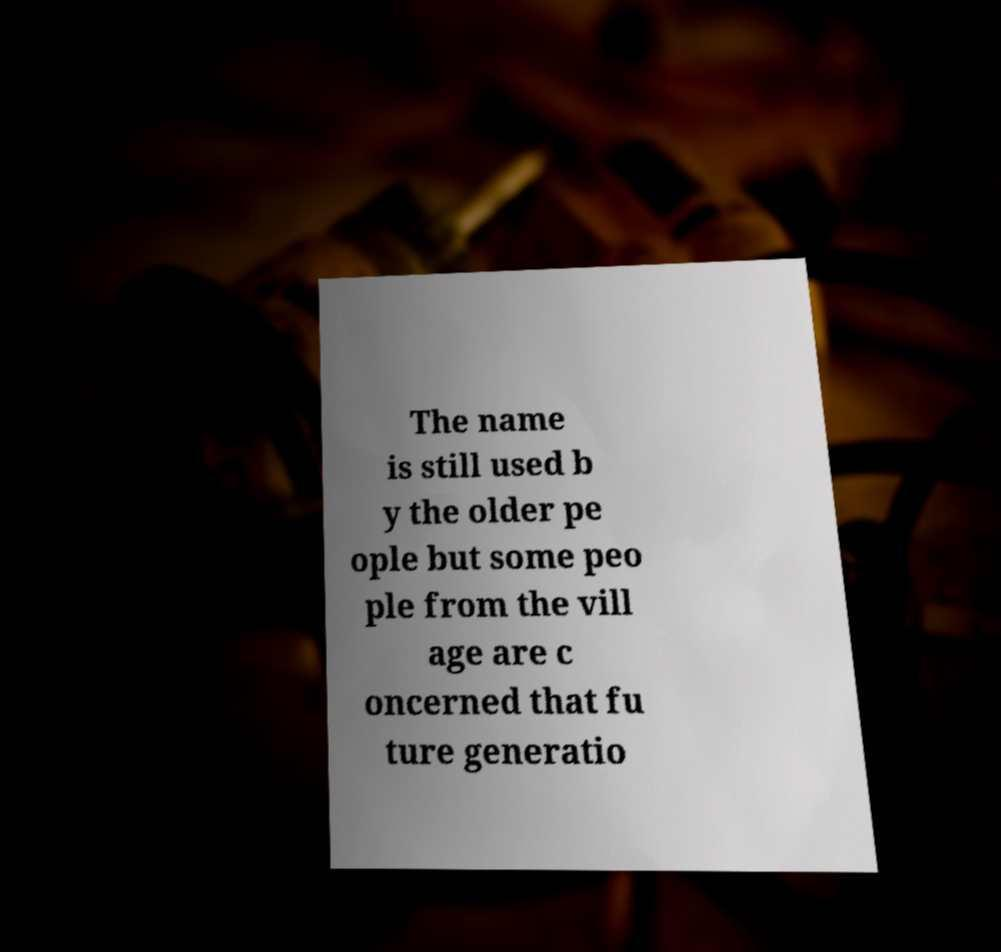Can you accurately transcribe the text from the provided image for me? The name is still used b y the older pe ople but some peo ple from the vill age are c oncerned that fu ture generatio 